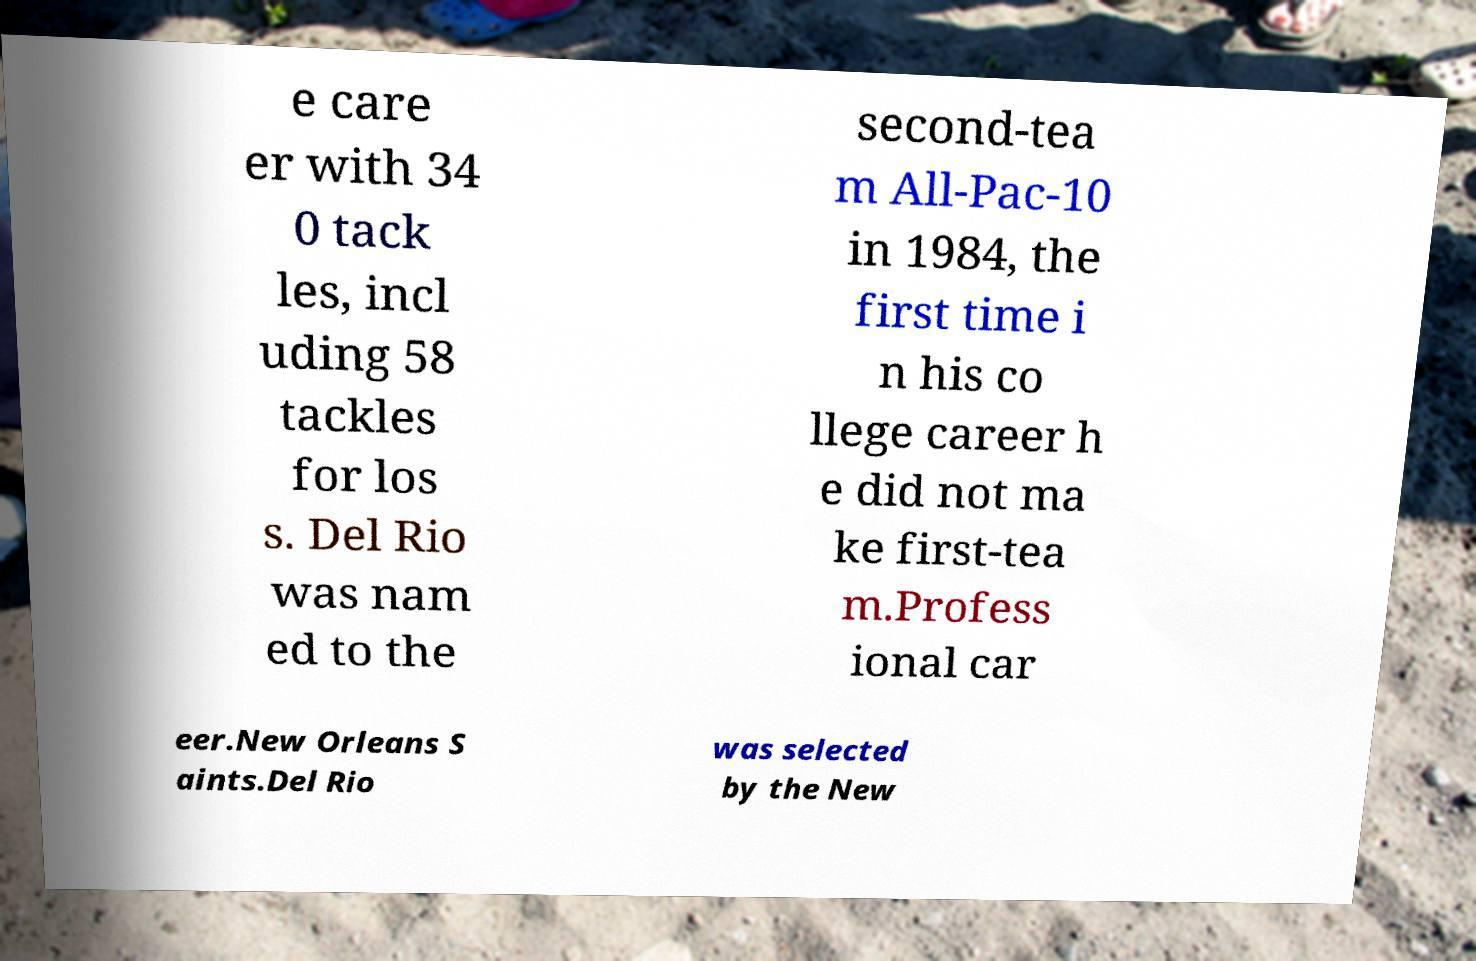Can you read and provide the text displayed in the image?This photo seems to have some interesting text. Can you extract and type it out for me? e care er with 34 0 tack les, incl uding 58 tackles for los s. Del Rio was nam ed to the second-tea m All-Pac-10 in 1984, the first time i n his co llege career h e did not ma ke first-tea m.Profess ional car eer.New Orleans S aints.Del Rio was selected by the New 